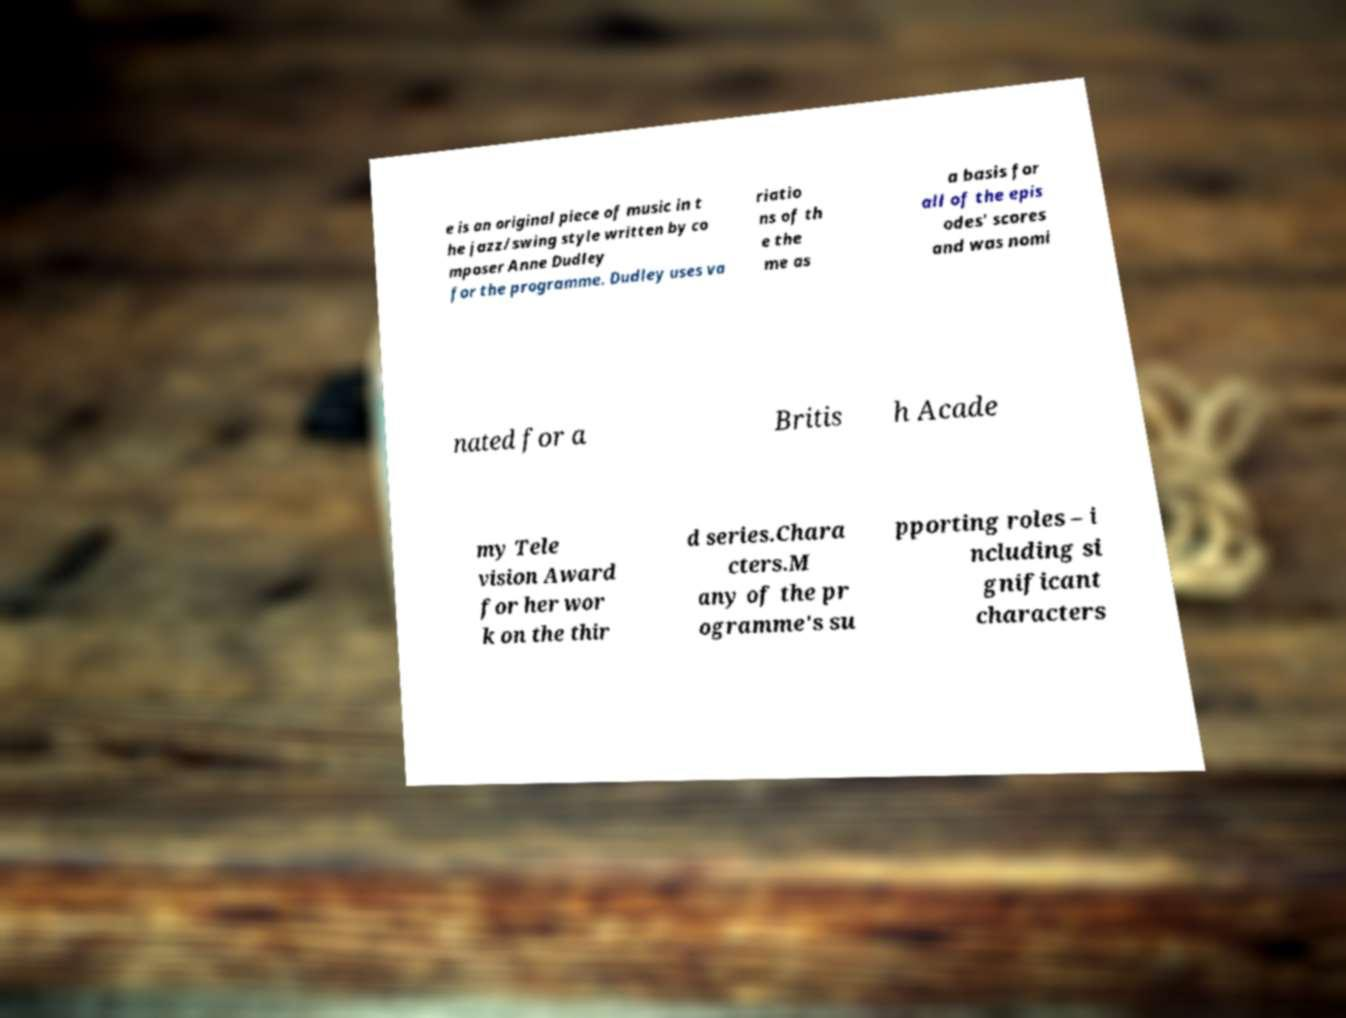Please read and relay the text visible in this image. What does it say? e is an original piece of music in t he jazz/swing style written by co mposer Anne Dudley for the programme. Dudley uses va riatio ns of th e the me as a basis for all of the epis odes' scores and was nomi nated for a Britis h Acade my Tele vision Award for her wor k on the thir d series.Chara cters.M any of the pr ogramme's su pporting roles – i ncluding si gnificant characters 